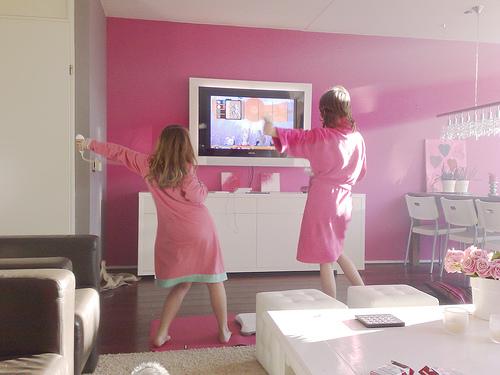What do candy hearts have in common with this room?
Keep it brief. Pink. What kind of game are these people playing?
Quick response, please. Wii. Do these people hate the color pink?
Write a very short answer. No. 